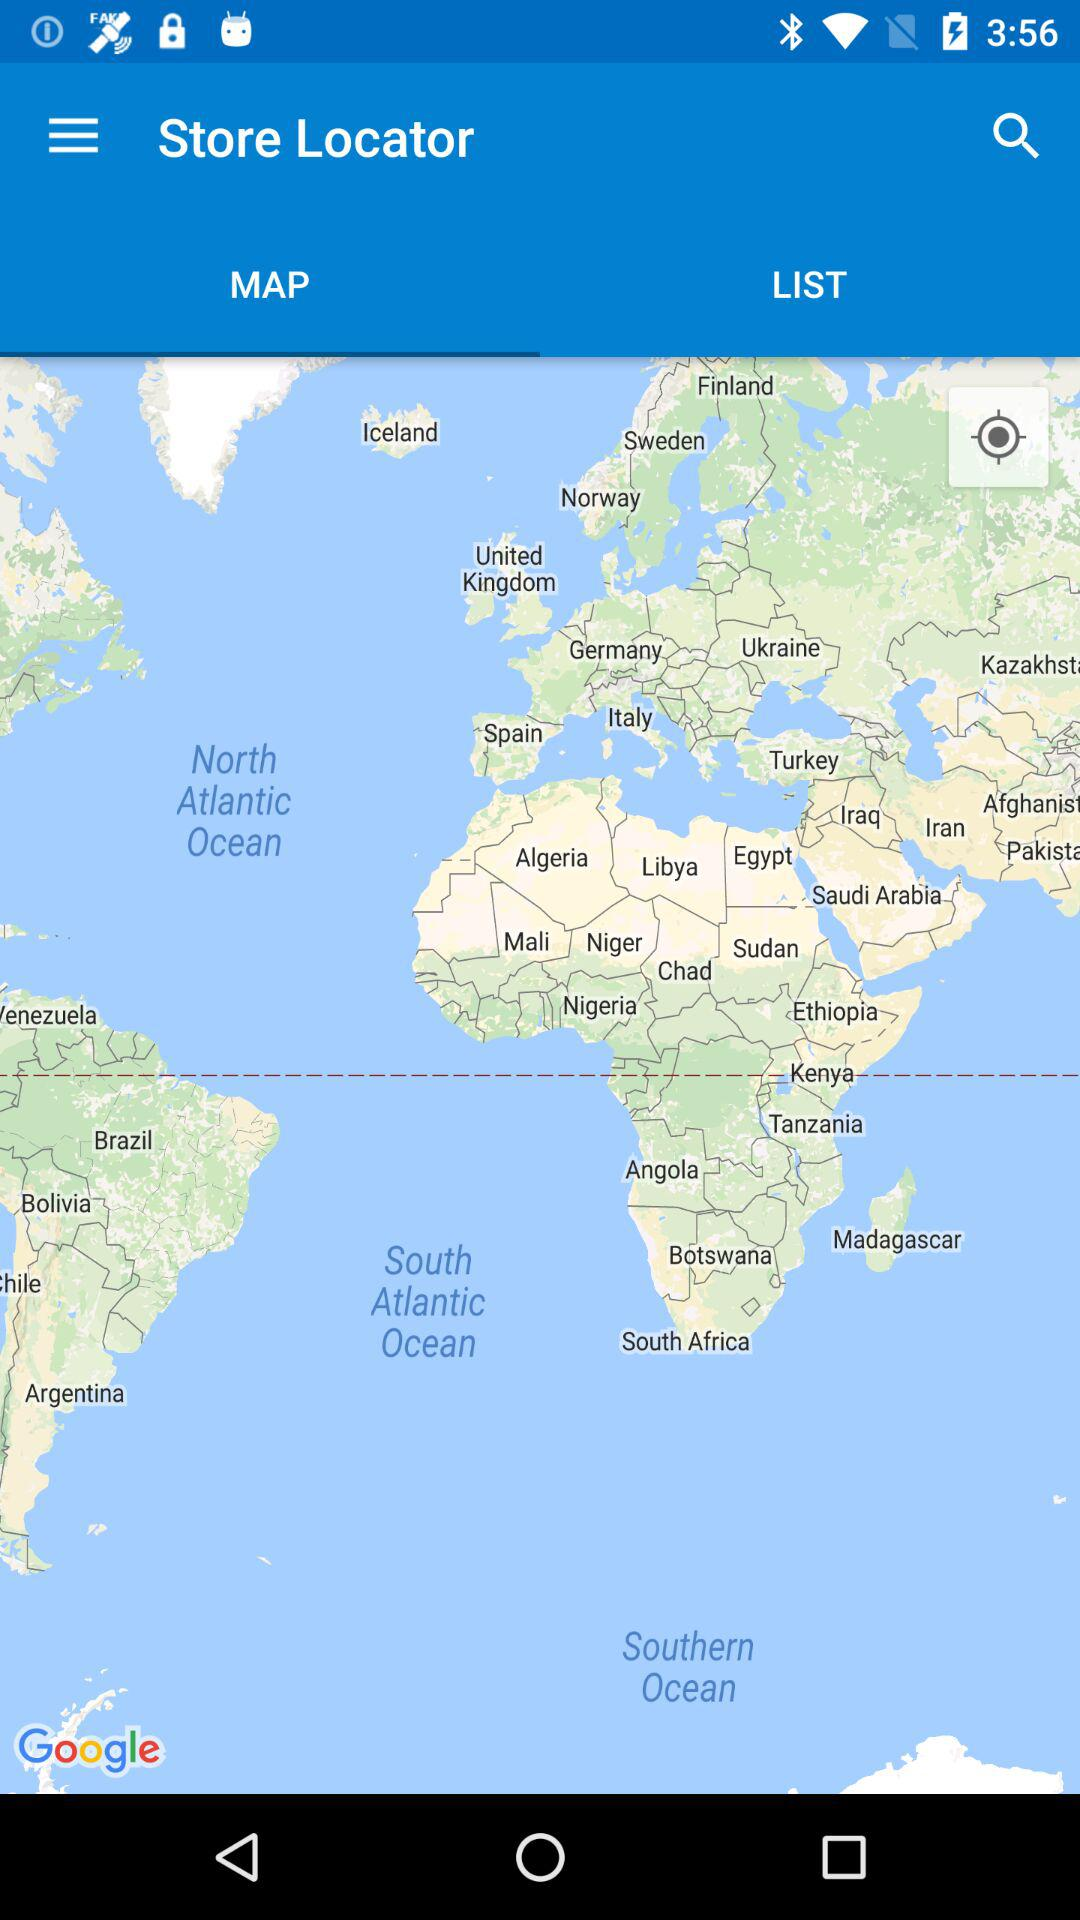What is the name of the application? The name of the application is "Store Locator". 